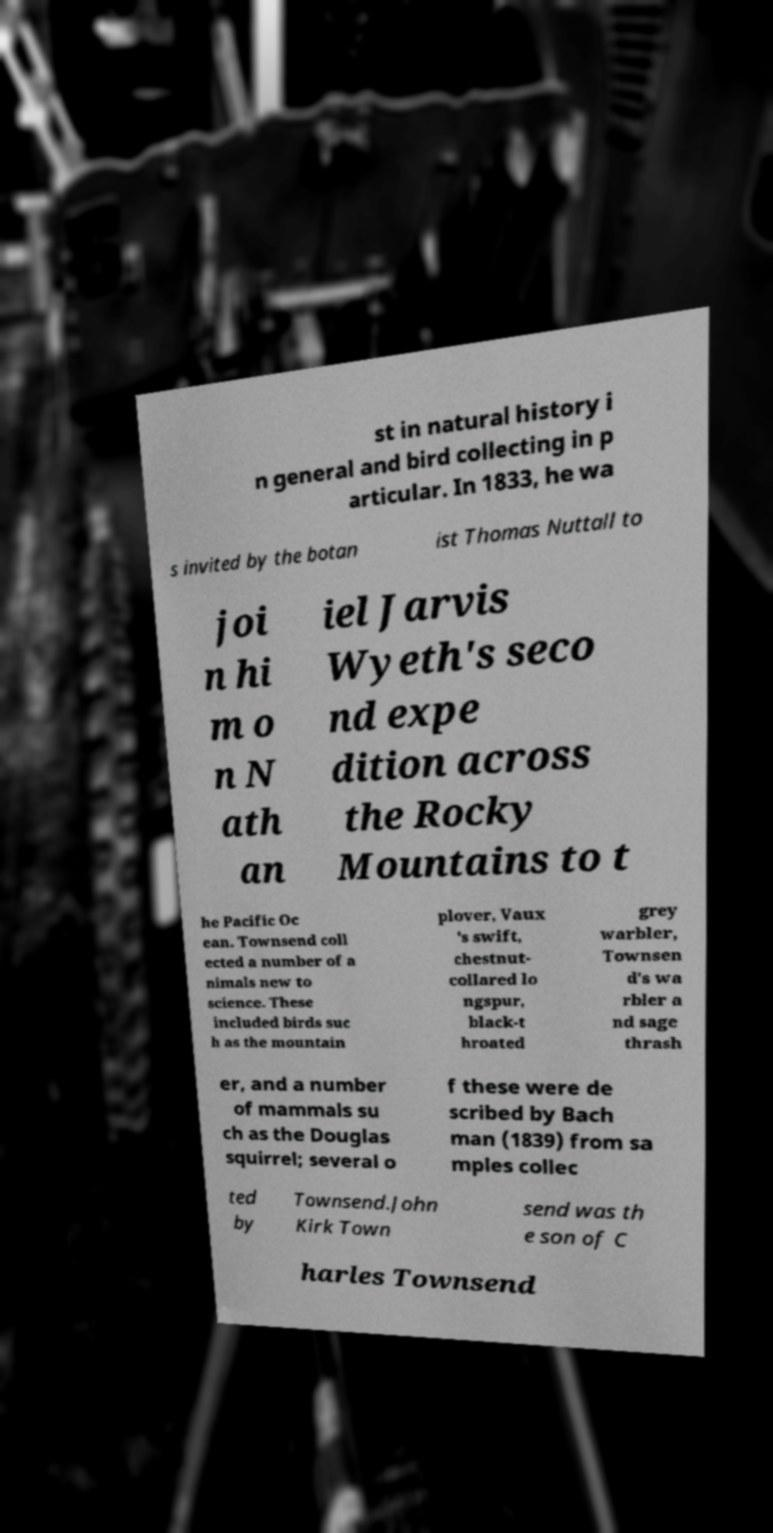What messages or text are displayed in this image? I need them in a readable, typed format. st in natural history i n general and bird collecting in p articular. In 1833, he wa s invited by the botan ist Thomas Nuttall to joi n hi m o n N ath an iel Jarvis Wyeth's seco nd expe dition across the Rocky Mountains to t he Pacific Oc ean. Townsend coll ected a number of a nimals new to science. These included birds suc h as the mountain plover, Vaux 's swift, chestnut- collared lo ngspur, black-t hroated grey warbler, Townsen d's wa rbler a nd sage thrash er, and a number of mammals su ch as the Douglas squirrel; several o f these were de scribed by Bach man (1839) from sa mples collec ted by Townsend.John Kirk Town send was th e son of C harles Townsend 